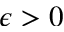<formula> <loc_0><loc_0><loc_500><loc_500>\epsilon > 0</formula> 